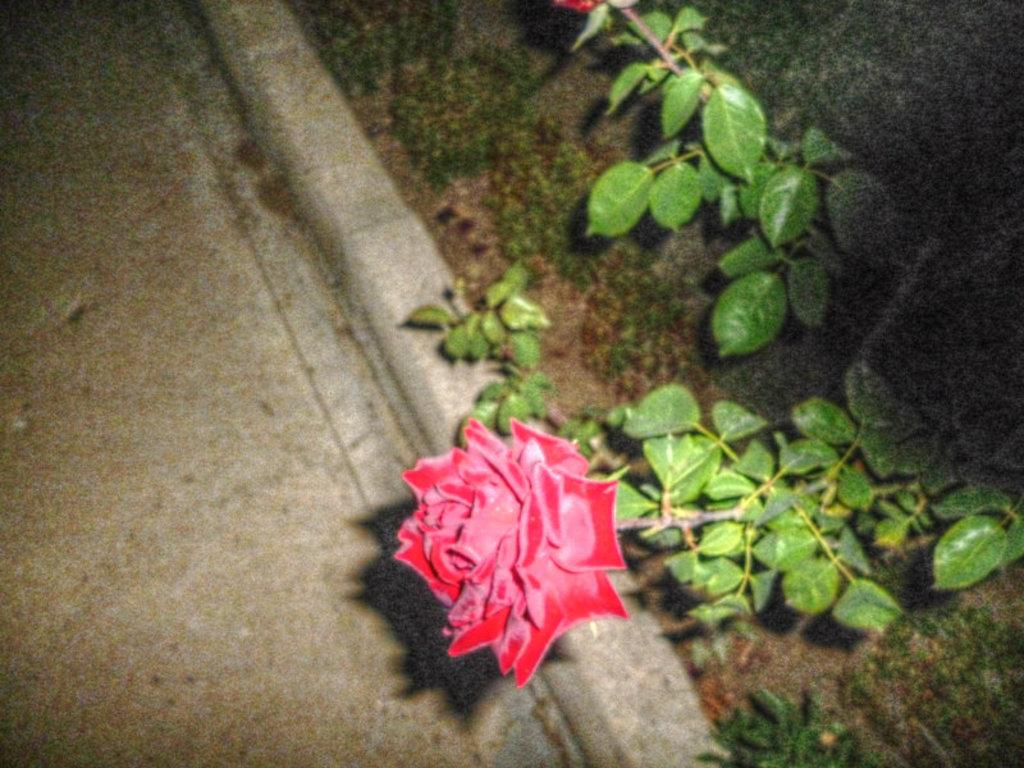What type of plant is visible in the image? There is a flower and a plant visible in the image. Where are the flower and plant located in the image? Both the flower and the plant are on the ground in the image. What color is the girl's hair in the image? There is no girl present in the image; it features a flower and a plant on the ground. 